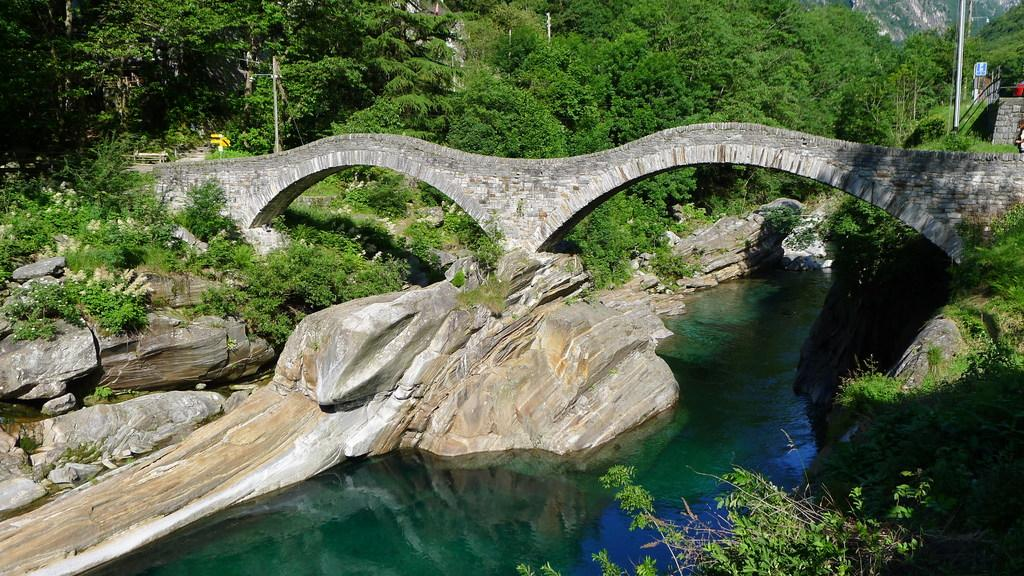What is happening in the image? Water is flowing in the image. What can be seen in the water? There are rocks and plants in the water. How can people or vehicles cross the water in the image? There is a bridge across the water. What is visible in the background of the image? Trees, poles, and mountains are visible in the background of the image. What type of soda is being poured into the water in the image? There is no soda present in the image; it features water flowing with rocks and plants. Can you see any branches in the image? There is no mention of branches in the provided facts, and none are visible in the image. 